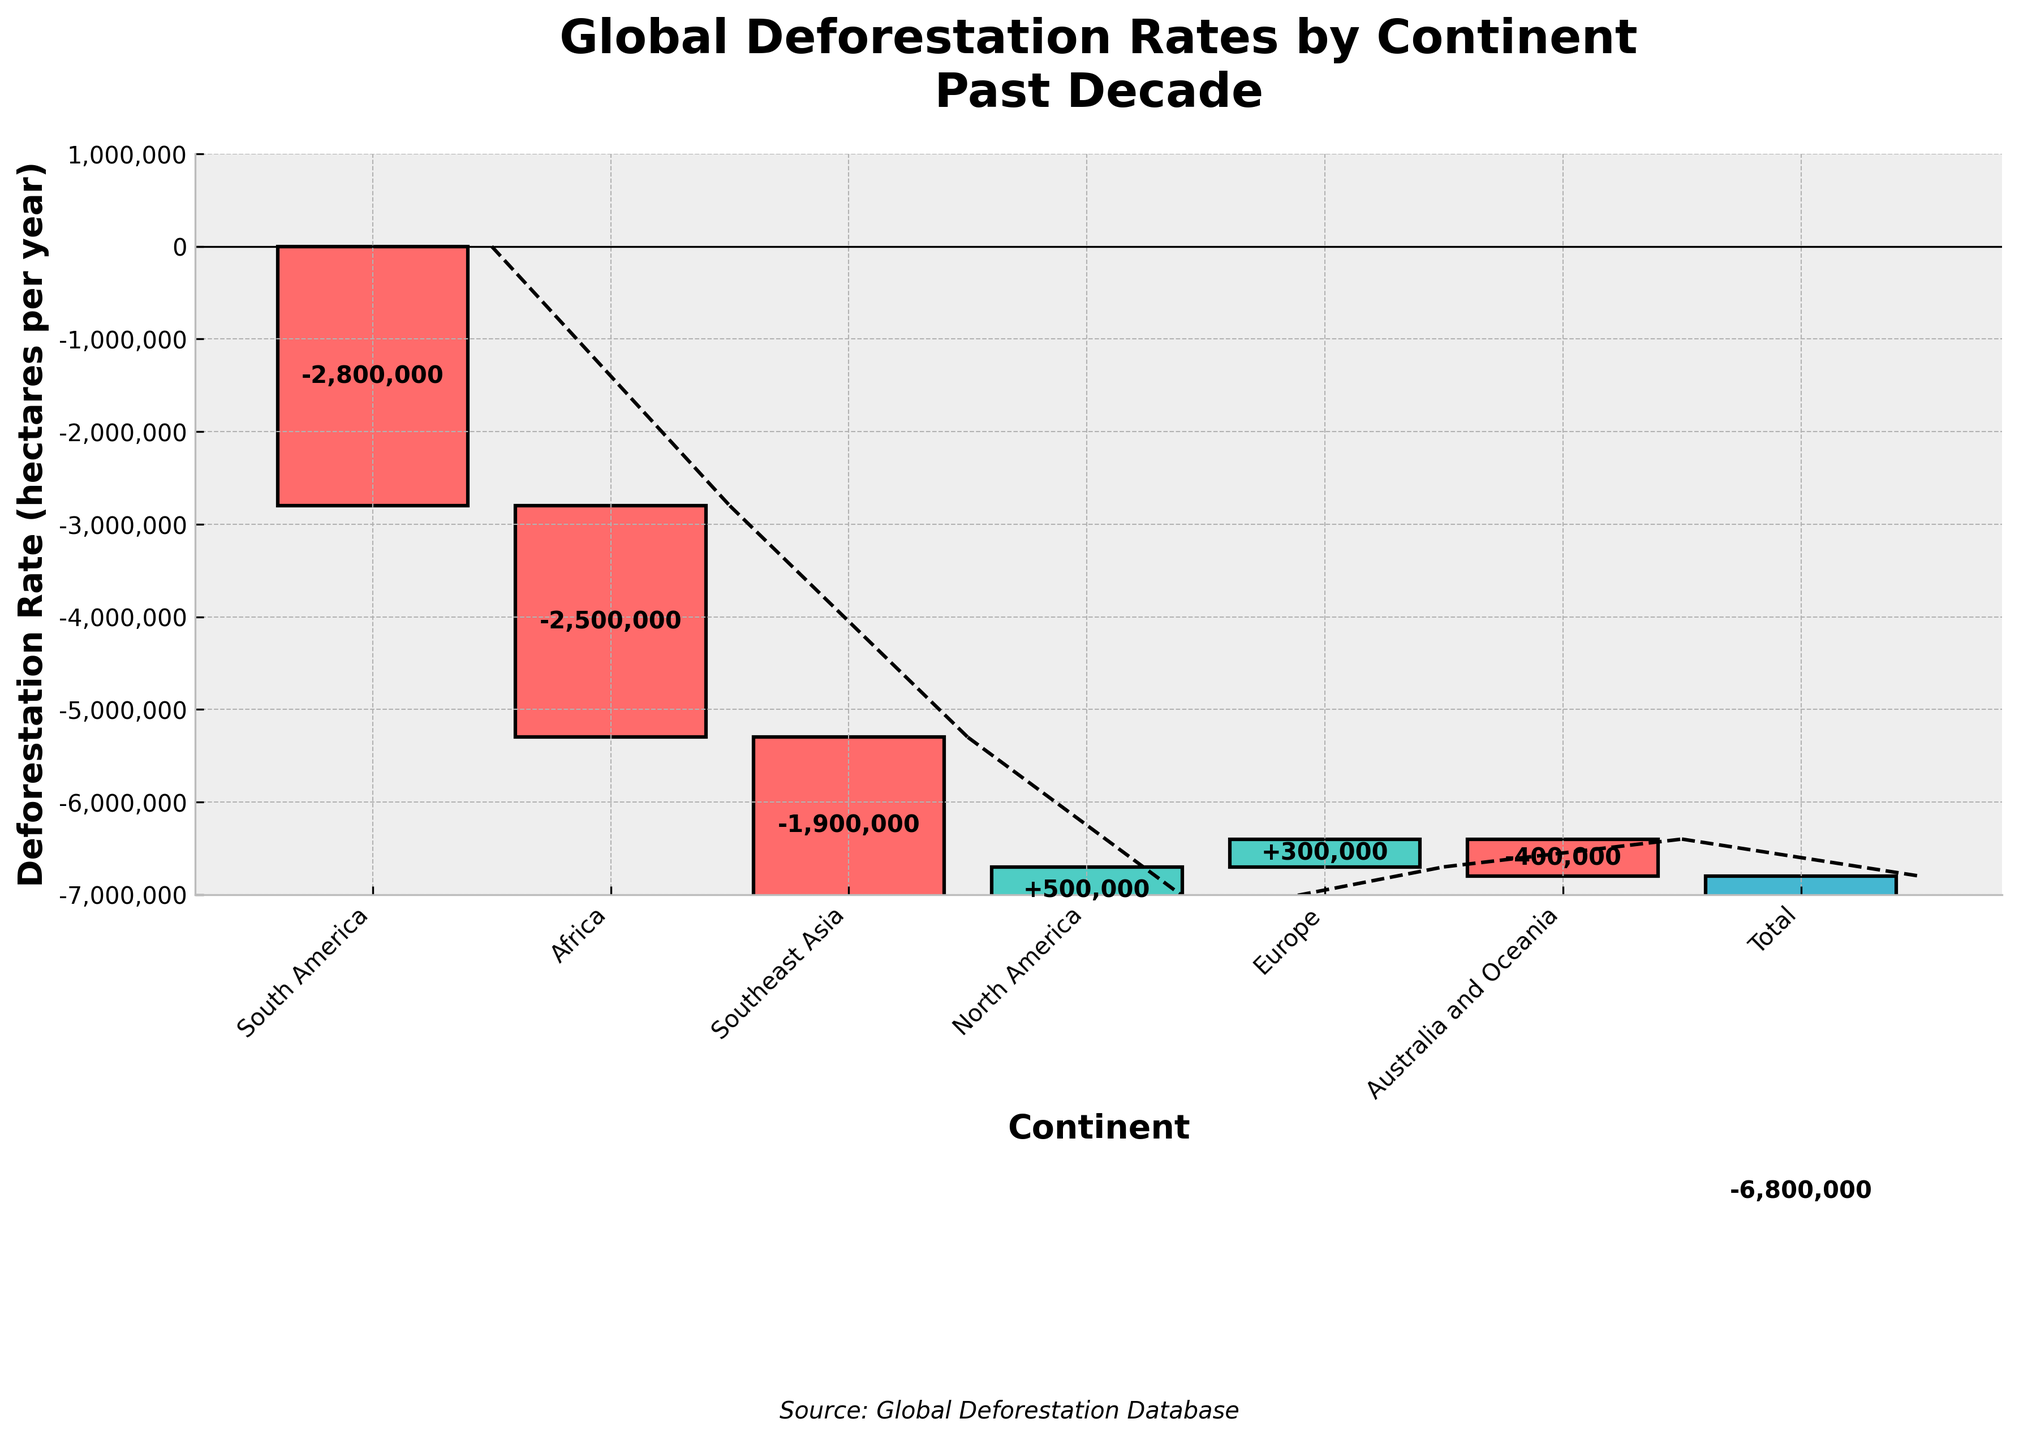What's the title of the figure? The title is located at the top of the figure, indicating the overall subject of the chart. It reads "Global Deforestation Rates by Continent\nPast Decade".
Answer: Global Deforestation Rates by Continent Past Decade Which continent has the highest rate of deforestation? By examining the height of the bars and the values on them, we can see that South America has the largest negative value for deforestation, which is -2,800,000 hectares per year.
Answer: South America What is the deforestation rate in Africa? The bar for Africa is labeled with the value and is the second bar from the left. The value indicated is -2,500,000 hectares per year.
Answer: -2,500,000 hectares per year Which continents have a positive deforestation rate? Positive deforestation rates will have bars extending upwards from the zero line. Both North America and Europe have upward bars, indicating positive values of +500,000 and +300,000 hectares per year, respectively.
Answer: North America and Europe What is the overall global deforestation rate for the past decade? The total global deforestation rate is represented by the final bar, which sums up all the previous values. The value shown for "Total" is -6,800,000 hectares per year.
Answer: -6,800,000 hectares per year How much more deforestation occurred in South America compared to Southeast Asia? Subtract the deforestation rate of Southeast Asia from that of South America. The rates are -2,800,000 and -1,900,000 hectares per year respectively. The difference is -2,800,000 - (-1,900,000) = -900,000 hectares per year.
Answer: 900,000 hectares per year more If you combine the deforestation rates of Africa and Australia and Oceania, what is the combined rate? Adding the deforestation rates of Africa (-2,500,000) and Australia and Oceania (-400,000), the combined rate is -2,500,000 + (-400,000) = -2,900,000 hectares per year.
Answer: -2,900,000 hectares per year Which continents have deforestation rates less than -500,000 hectares per year? Checking the bars visually, South America (-2,800,000), Africa (-2,500,000), Southeast Asia (-1,900,000), and Australia and Oceania (-400,000) all meet this criterion.
Answer: South America, Africa, Southeast Asia, Australia and Oceania What is the difference in deforestation rates between the continents with the highest and lowest rates? The continent with the highest deforestation rate is South America (-2,800,000), while the one with the lowest is Australia and Oceania (-400,000). The difference is -2,800,000 - (-400,000) = -2,400,000 hectares per year.
Answer: 2,400,000 hectares per year 